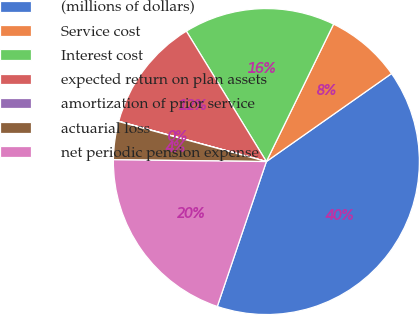<chart> <loc_0><loc_0><loc_500><loc_500><pie_chart><fcel>(millions of dollars)<fcel>Service cost<fcel>Interest cost<fcel>expected return on plan assets<fcel>amortization of prior service<fcel>actuarial loss<fcel>net periodic pension expense<nl><fcel>39.95%<fcel>8.01%<fcel>16.0%<fcel>12.0%<fcel>0.03%<fcel>4.02%<fcel>19.99%<nl></chart> 